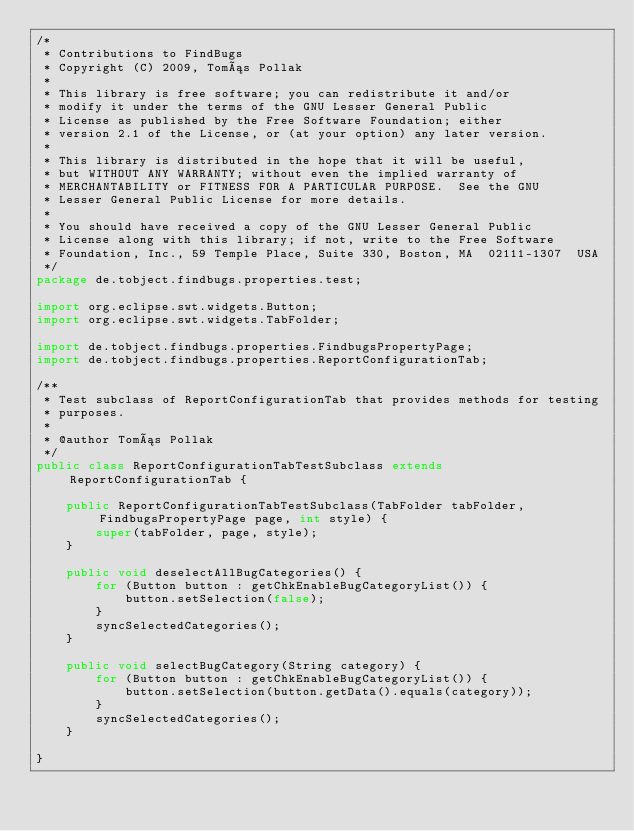<code> <loc_0><loc_0><loc_500><loc_500><_Java_>/*
 * Contributions to FindBugs
 * Copyright (C) 2009, Tomás Pollak
 *
 * This library is free software; you can redistribute it and/or
 * modify it under the terms of the GNU Lesser General Public
 * License as published by the Free Software Foundation; either
 * version 2.1 of the License, or (at your option) any later version.
 *
 * This library is distributed in the hope that it will be useful,
 * but WITHOUT ANY WARRANTY; without even the implied warranty of
 * MERCHANTABILITY or FITNESS FOR A PARTICULAR PURPOSE.  See the GNU
 * Lesser General Public License for more details.
 *
 * You should have received a copy of the GNU Lesser General Public
 * License along with this library; if not, write to the Free Software
 * Foundation, Inc., 59 Temple Place, Suite 330, Boston, MA  02111-1307  USA
 */
package de.tobject.findbugs.properties.test;

import org.eclipse.swt.widgets.Button;
import org.eclipse.swt.widgets.TabFolder;

import de.tobject.findbugs.properties.FindbugsPropertyPage;
import de.tobject.findbugs.properties.ReportConfigurationTab;

/**
 * Test subclass of ReportConfigurationTab that provides methods for testing
 * purposes.
 *
 * @author Tomás Pollak
 */
public class ReportConfigurationTabTestSubclass extends ReportConfigurationTab {

    public ReportConfigurationTabTestSubclass(TabFolder tabFolder, FindbugsPropertyPage page, int style) {
        super(tabFolder, page, style);
    }

    public void deselectAllBugCategories() {
        for (Button button : getChkEnableBugCategoryList()) {
            button.setSelection(false);
        }
        syncSelectedCategories();
    }

    public void selectBugCategory(String category) {
        for (Button button : getChkEnableBugCategoryList()) {
            button.setSelection(button.getData().equals(category));
        }
        syncSelectedCategories();
    }

}
</code> 